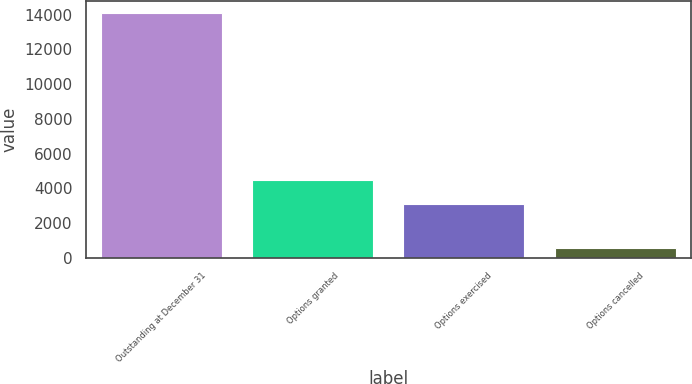<chart> <loc_0><loc_0><loc_500><loc_500><bar_chart><fcel>Outstanding at December 31<fcel>Options granted<fcel>Options exercised<fcel>Options cancelled<nl><fcel>14107<fcel>4494<fcel>3134<fcel>584<nl></chart> 